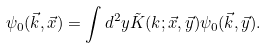<formula> <loc_0><loc_0><loc_500><loc_500>\psi _ { 0 } ( \vec { k } , \vec { x } ) = \int d ^ { 2 } y \tilde { K } ( k ; \vec { x } , \vec { y } ) \psi _ { 0 } ( \vec { k } , \vec { y } ) .</formula> 